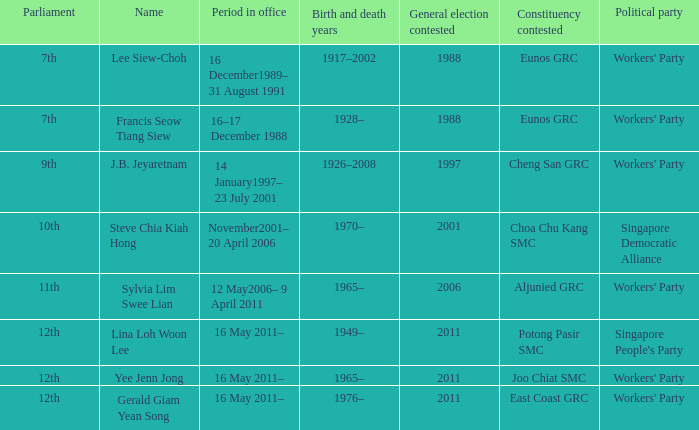During what period were parliament 11th? 12 May2006– 9 April 2011. 